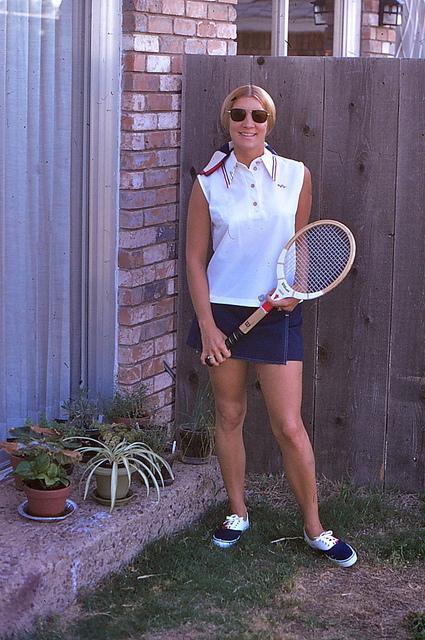How many potted plants are there?
Give a very brief answer. 3. How many people can you see?
Give a very brief answer. 1. 